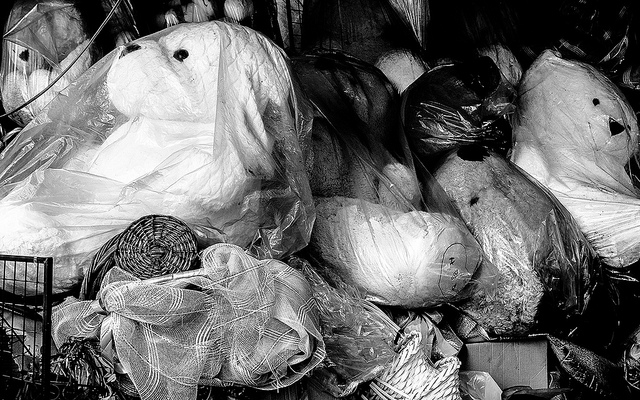How many teddy bears are there? It's difficult to provide an accurate count without a clear view, but based on the visible parts, there do not appear to be any teddy bears in this image. Instead, we can see various items, possibly in a storage area or shop, wrapped in plastic, which may include household objects, decorations, or other stuffed animals. 